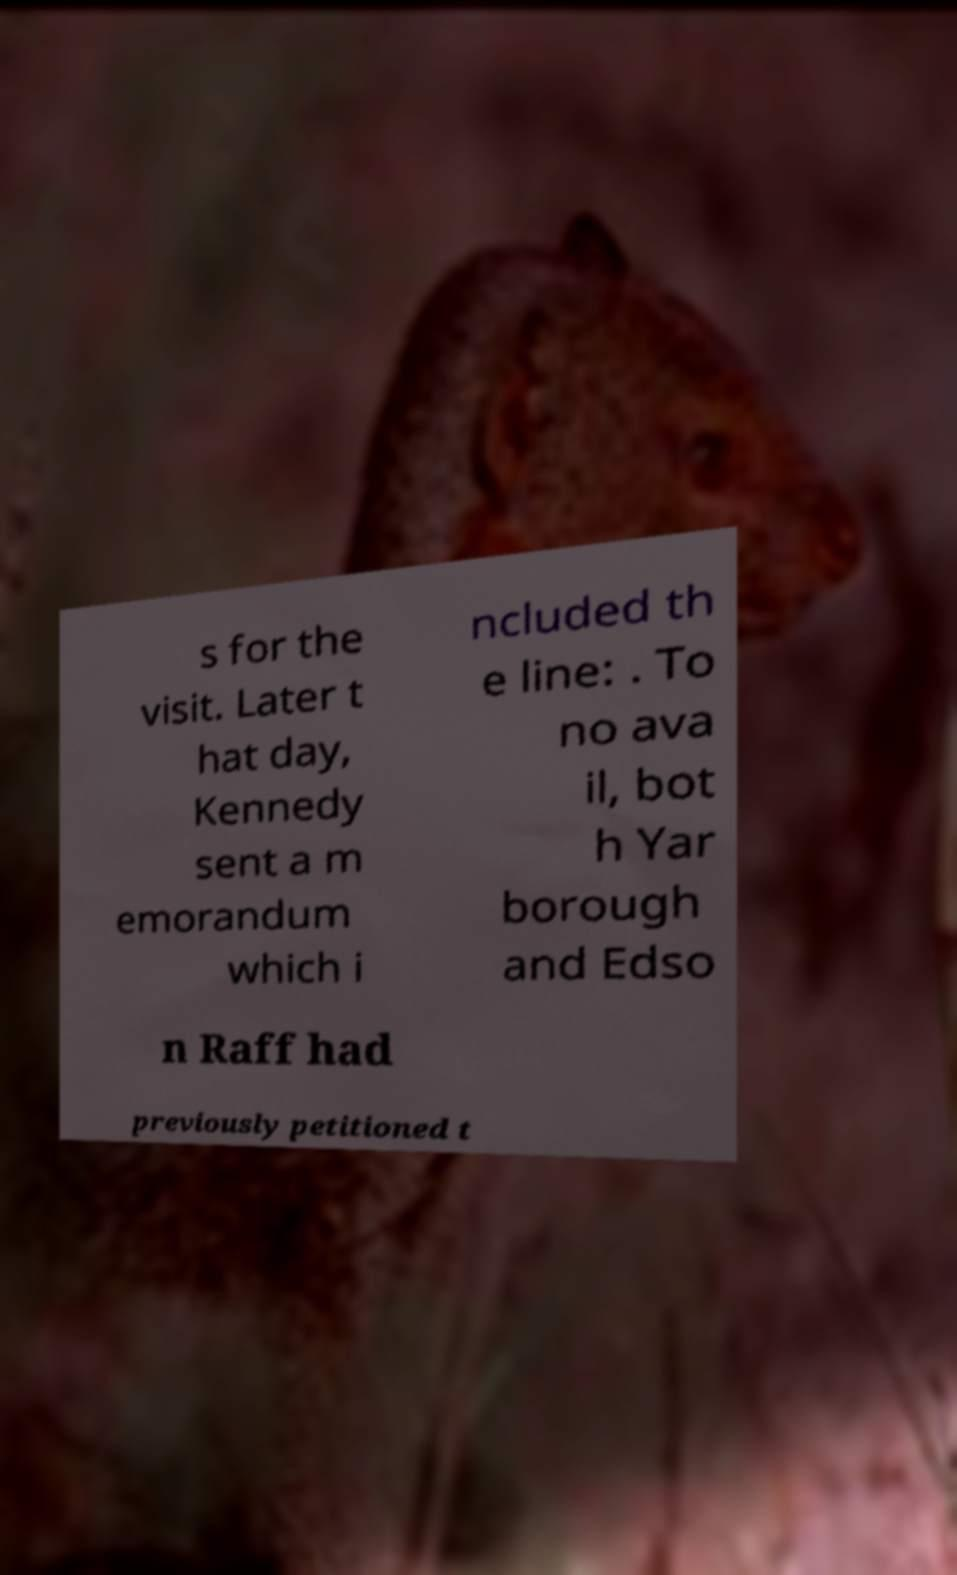Can you read and provide the text displayed in the image?This photo seems to have some interesting text. Can you extract and type it out for me? s for the visit. Later t hat day, Kennedy sent a m emorandum which i ncluded th e line: . To no ava il, bot h Yar borough and Edso n Raff had previously petitioned t 